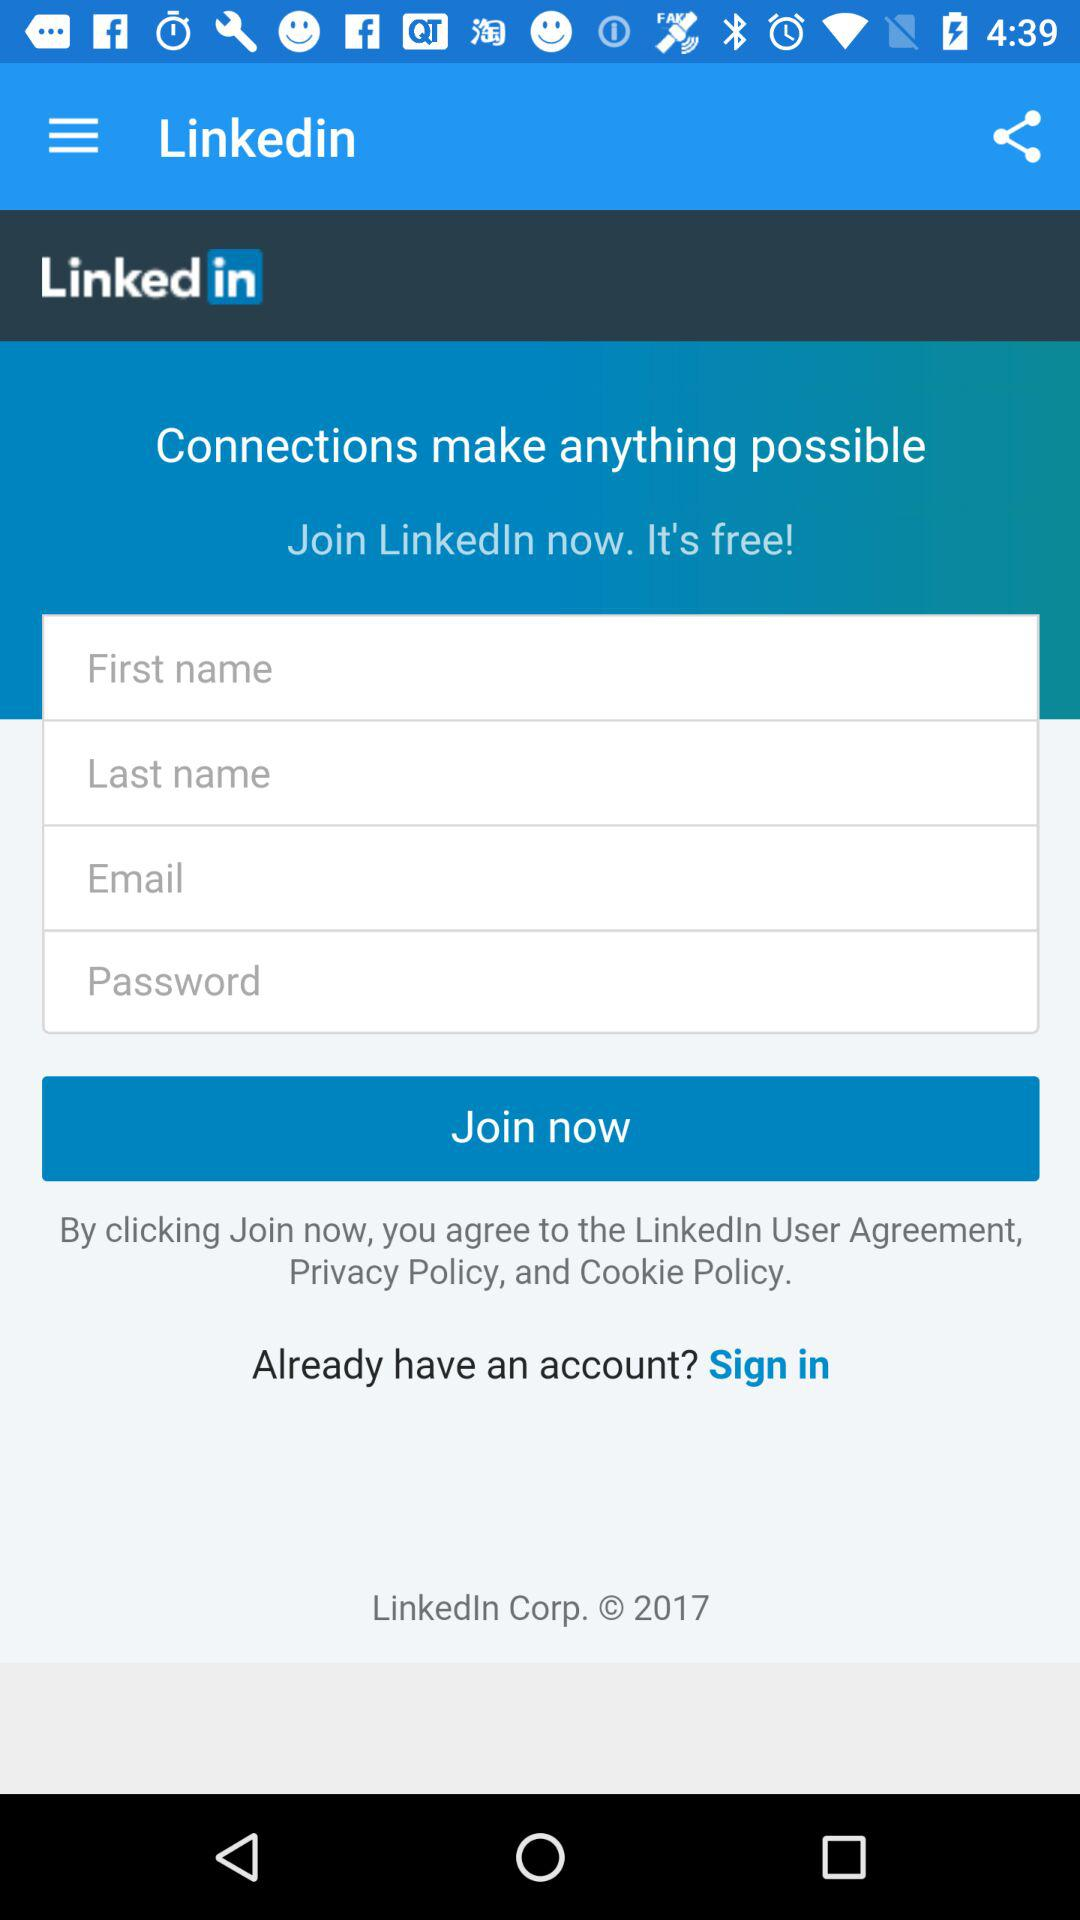How many text inputs are there for the user to fill out?
Answer the question using a single word or phrase. 4 